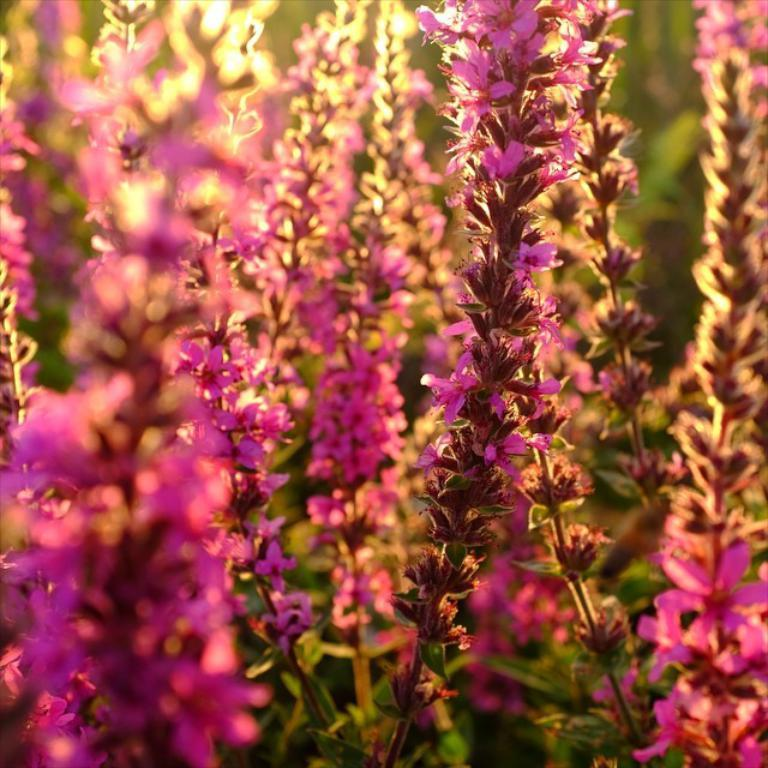What color are the flowers in the image? The flowers in the image are pink. What can be seen in the background of the image? There are plants in green color in the background of the image. What type of screw can be seen holding the flowers in the image? There is no screw present in the image; the flowers are not attached to anything. 